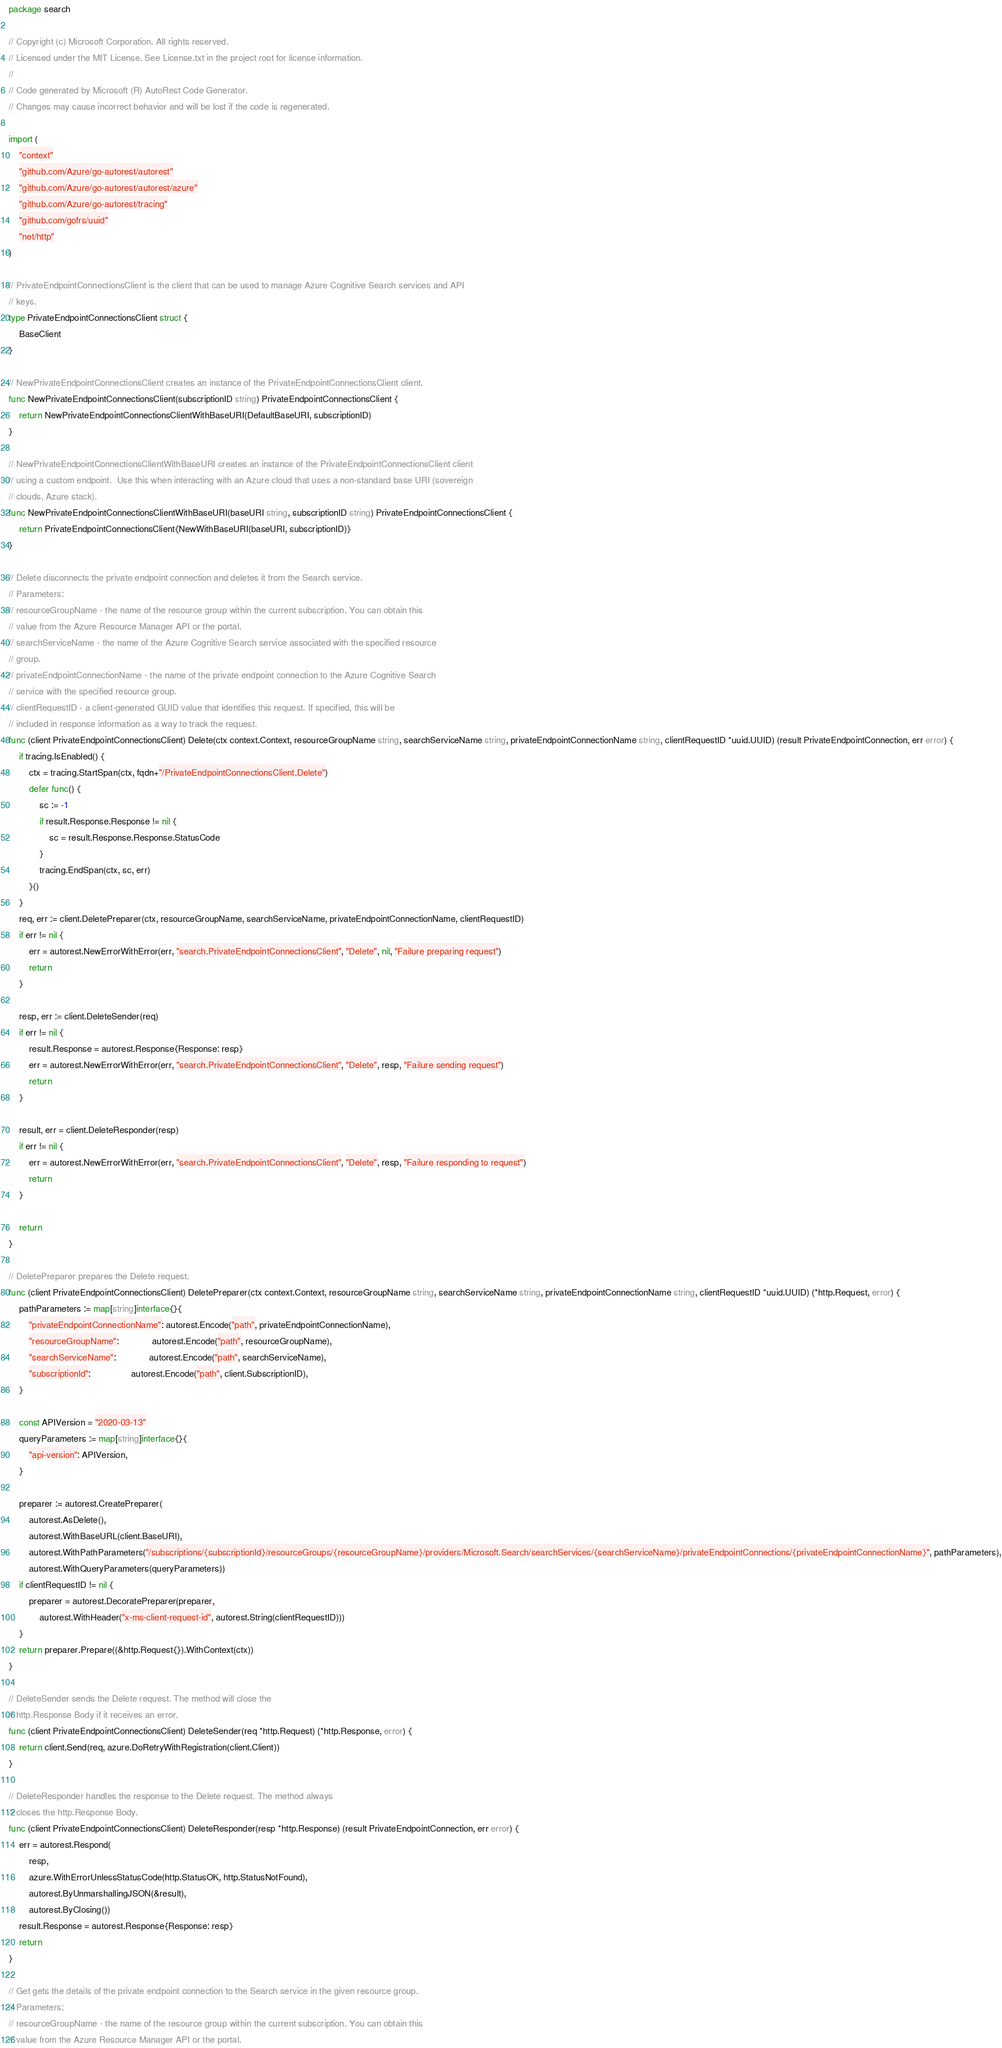<code> <loc_0><loc_0><loc_500><loc_500><_Go_>package search

// Copyright (c) Microsoft Corporation. All rights reserved.
// Licensed under the MIT License. See License.txt in the project root for license information.
//
// Code generated by Microsoft (R) AutoRest Code Generator.
// Changes may cause incorrect behavior and will be lost if the code is regenerated.

import (
	"context"
	"github.com/Azure/go-autorest/autorest"
	"github.com/Azure/go-autorest/autorest/azure"
	"github.com/Azure/go-autorest/tracing"
	"github.com/gofrs/uuid"
	"net/http"
)

// PrivateEndpointConnectionsClient is the client that can be used to manage Azure Cognitive Search services and API
// keys.
type PrivateEndpointConnectionsClient struct {
	BaseClient
}

// NewPrivateEndpointConnectionsClient creates an instance of the PrivateEndpointConnectionsClient client.
func NewPrivateEndpointConnectionsClient(subscriptionID string) PrivateEndpointConnectionsClient {
	return NewPrivateEndpointConnectionsClientWithBaseURI(DefaultBaseURI, subscriptionID)
}

// NewPrivateEndpointConnectionsClientWithBaseURI creates an instance of the PrivateEndpointConnectionsClient client
// using a custom endpoint.  Use this when interacting with an Azure cloud that uses a non-standard base URI (sovereign
// clouds, Azure stack).
func NewPrivateEndpointConnectionsClientWithBaseURI(baseURI string, subscriptionID string) PrivateEndpointConnectionsClient {
	return PrivateEndpointConnectionsClient{NewWithBaseURI(baseURI, subscriptionID)}
}

// Delete disconnects the private endpoint connection and deletes it from the Search service.
// Parameters:
// resourceGroupName - the name of the resource group within the current subscription. You can obtain this
// value from the Azure Resource Manager API or the portal.
// searchServiceName - the name of the Azure Cognitive Search service associated with the specified resource
// group.
// privateEndpointConnectionName - the name of the private endpoint connection to the Azure Cognitive Search
// service with the specified resource group.
// clientRequestID - a client-generated GUID value that identifies this request. If specified, this will be
// included in response information as a way to track the request.
func (client PrivateEndpointConnectionsClient) Delete(ctx context.Context, resourceGroupName string, searchServiceName string, privateEndpointConnectionName string, clientRequestID *uuid.UUID) (result PrivateEndpointConnection, err error) {
	if tracing.IsEnabled() {
		ctx = tracing.StartSpan(ctx, fqdn+"/PrivateEndpointConnectionsClient.Delete")
		defer func() {
			sc := -1
			if result.Response.Response != nil {
				sc = result.Response.Response.StatusCode
			}
			tracing.EndSpan(ctx, sc, err)
		}()
	}
	req, err := client.DeletePreparer(ctx, resourceGroupName, searchServiceName, privateEndpointConnectionName, clientRequestID)
	if err != nil {
		err = autorest.NewErrorWithError(err, "search.PrivateEndpointConnectionsClient", "Delete", nil, "Failure preparing request")
		return
	}

	resp, err := client.DeleteSender(req)
	if err != nil {
		result.Response = autorest.Response{Response: resp}
		err = autorest.NewErrorWithError(err, "search.PrivateEndpointConnectionsClient", "Delete", resp, "Failure sending request")
		return
	}

	result, err = client.DeleteResponder(resp)
	if err != nil {
		err = autorest.NewErrorWithError(err, "search.PrivateEndpointConnectionsClient", "Delete", resp, "Failure responding to request")
		return
	}

	return
}

// DeletePreparer prepares the Delete request.
func (client PrivateEndpointConnectionsClient) DeletePreparer(ctx context.Context, resourceGroupName string, searchServiceName string, privateEndpointConnectionName string, clientRequestID *uuid.UUID) (*http.Request, error) {
	pathParameters := map[string]interface{}{
		"privateEndpointConnectionName": autorest.Encode("path", privateEndpointConnectionName),
		"resourceGroupName":             autorest.Encode("path", resourceGroupName),
		"searchServiceName":             autorest.Encode("path", searchServiceName),
		"subscriptionId":                autorest.Encode("path", client.SubscriptionID),
	}

	const APIVersion = "2020-03-13"
	queryParameters := map[string]interface{}{
		"api-version": APIVersion,
	}

	preparer := autorest.CreatePreparer(
		autorest.AsDelete(),
		autorest.WithBaseURL(client.BaseURI),
		autorest.WithPathParameters("/subscriptions/{subscriptionId}/resourceGroups/{resourceGroupName}/providers/Microsoft.Search/searchServices/{searchServiceName}/privateEndpointConnections/{privateEndpointConnectionName}", pathParameters),
		autorest.WithQueryParameters(queryParameters))
	if clientRequestID != nil {
		preparer = autorest.DecoratePreparer(preparer,
			autorest.WithHeader("x-ms-client-request-id", autorest.String(clientRequestID)))
	}
	return preparer.Prepare((&http.Request{}).WithContext(ctx))
}

// DeleteSender sends the Delete request. The method will close the
// http.Response Body if it receives an error.
func (client PrivateEndpointConnectionsClient) DeleteSender(req *http.Request) (*http.Response, error) {
	return client.Send(req, azure.DoRetryWithRegistration(client.Client))
}

// DeleteResponder handles the response to the Delete request. The method always
// closes the http.Response Body.
func (client PrivateEndpointConnectionsClient) DeleteResponder(resp *http.Response) (result PrivateEndpointConnection, err error) {
	err = autorest.Respond(
		resp,
		azure.WithErrorUnlessStatusCode(http.StatusOK, http.StatusNotFound),
		autorest.ByUnmarshallingJSON(&result),
		autorest.ByClosing())
	result.Response = autorest.Response{Response: resp}
	return
}

// Get gets the details of the private endpoint connection to the Search service in the given resource group.
// Parameters:
// resourceGroupName - the name of the resource group within the current subscription. You can obtain this
// value from the Azure Resource Manager API or the portal.</code> 